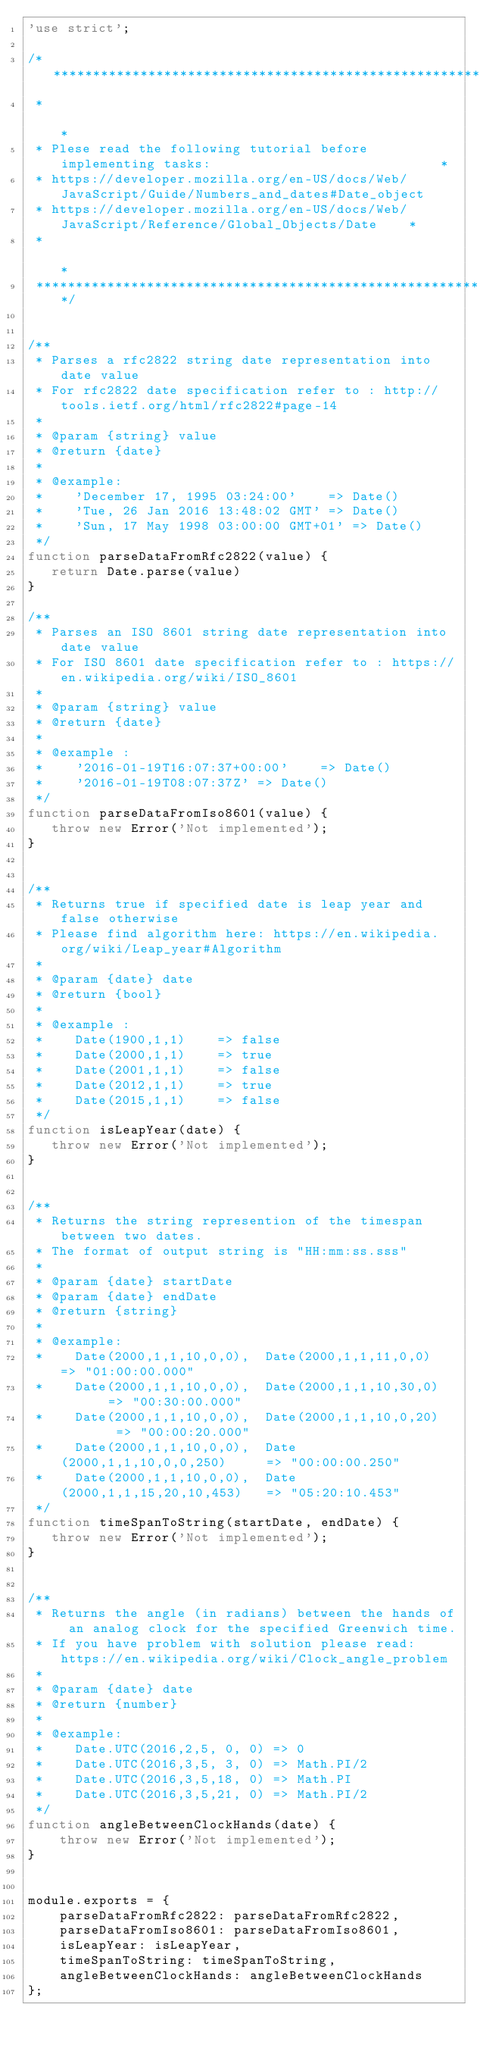Convert code to text. <code><loc_0><loc_0><loc_500><loc_500><_JavaScript_>'use strict';

/********************************************************************************************
 *                                                                                          *
 * Plese read the following tutorial before implementing tasks:                             *
 * https://developer.mozilla.org/en-US/docs/Web/JavaScript/Guide/Numbers_and_dates#Date_object
 * https://developer.mozilla.org/en-US/docs/Web/JavaScript/Reference/Global_Objects/Date    *
 *                                                                                          *
 ********************************************************************************************/


/**
 * Parses a rfc2822 string date representation into date value
 * For rfc2822 date specification refer to : http://tools.ietf.org/html/rfc2822#page-14
 *
 * @param {string} value
 * @return {date}
 *
 * @example:
 *    'December 17, 1995 03:24:00'    => Date()
 *    'Tue, 26 Jan 2016 13:48:02 GMT' => Date()
 *    'Sun, 17 May 1998 03:00:00 GMT+01' => Date()
 */
function parseDataFromRfc2822(value) {
   return Date.parse(value)
}

/**
 * Parses an ISO 8601 string date representation into date value
 * For ISO 8601 date specification refer to : https://en.wikipedia.org/wiki/ISO_8601
 *
 * @param {string} value
 * @return {date}
 *
 * @example :
 *    '2016-01-19T16:07:37+00:00'    => Date()
 *    '2016-01-19T08:07:37Z' => Date()
 */
function parseDataFromIso8601(value) {
   throw new Error('Not implemented');
}


/**
 * Returns true if specified date is leap year and false otherwise
 * Please find algorithm here: https://en.wikipedia.org/wiki/Leap_year#Algorithm
 *
 * @param {date} date
 * @return {bool}
 *
 * @example :
 *    Date(1900,1,1)    => false
 *    Date(2000,1,1)    => true
 *    Date(2001,1,1)    => false
 *    Date(2012,1,1)    => true
 *    Date(2015,1,1)    => false
 */
function isLeapYear(date) {
   throw new Error('Not implemented');
}


/**
 * Returns the string represention of the timespan between two dates.
 * The format of output string is "HH:mm:ss.sss"
 *
 * @param {date} startDate
 * @param {date} endDate
 * @return {string}
 *
 * @example:
 *    Date(2000,1,1,10,0,0),  Date(2000,1,1,11,0,0)   => "01:00:00.000"
 *    Date(2000,1,1,10,0,0),  Date(2000,1,1,10,30,0)       => "00:30:00.000"
 *    Date(2000,1,1,10,0,0),  Date(2000,1,1,10,0,20)        => "00:00:20.000"
 *    Date(2000,1,1,10,0,0),  Date(2000,1,1,10,0,0,250)     => "00:00:00.250"
 *    Date(2000,1,1,10,0,0),  Date(2000,1,1,15,20,10,453)   => "05:20:10.453"
 */
function timeSpanToString(startDate, endDate) {
   throw new Error('Not implemented');
}


/**
 * Returns the angle (in radians) between the hands of an analog clock for the specified Greenwich time.
 * If you have problem with solution please read: https://en.wikipedia.org/wiki/Clock_angle_problem
 * 
 * @param {date} date
 * @return {number}
 *
 * @example:
 *    Date.UTC(2016,2,5, 0, 0) => 0
 *    Date.UTC(2016,3,5, 3, 0) => Math.PI/2
 *    Date.UTC(2016,3,5,18, 0) => Math.PI
 *    Date.UTC(2016,3,5,21, 0) => Math.PI/2
 */
function angleBetweenClockHands(date) {
    throw new Error('Not implemented');
}


module.exports = {
    parseDataFromRfc2822: parseDataFromRfc2822,
    parseDataFromIso8601: parseDataFromIso8601,
    isLeapYear: isLeapYear,
    timeSpanToString: timeSpanToString,
    angleBetweenClockHands: angleBetweenClockHands
};
</code> 